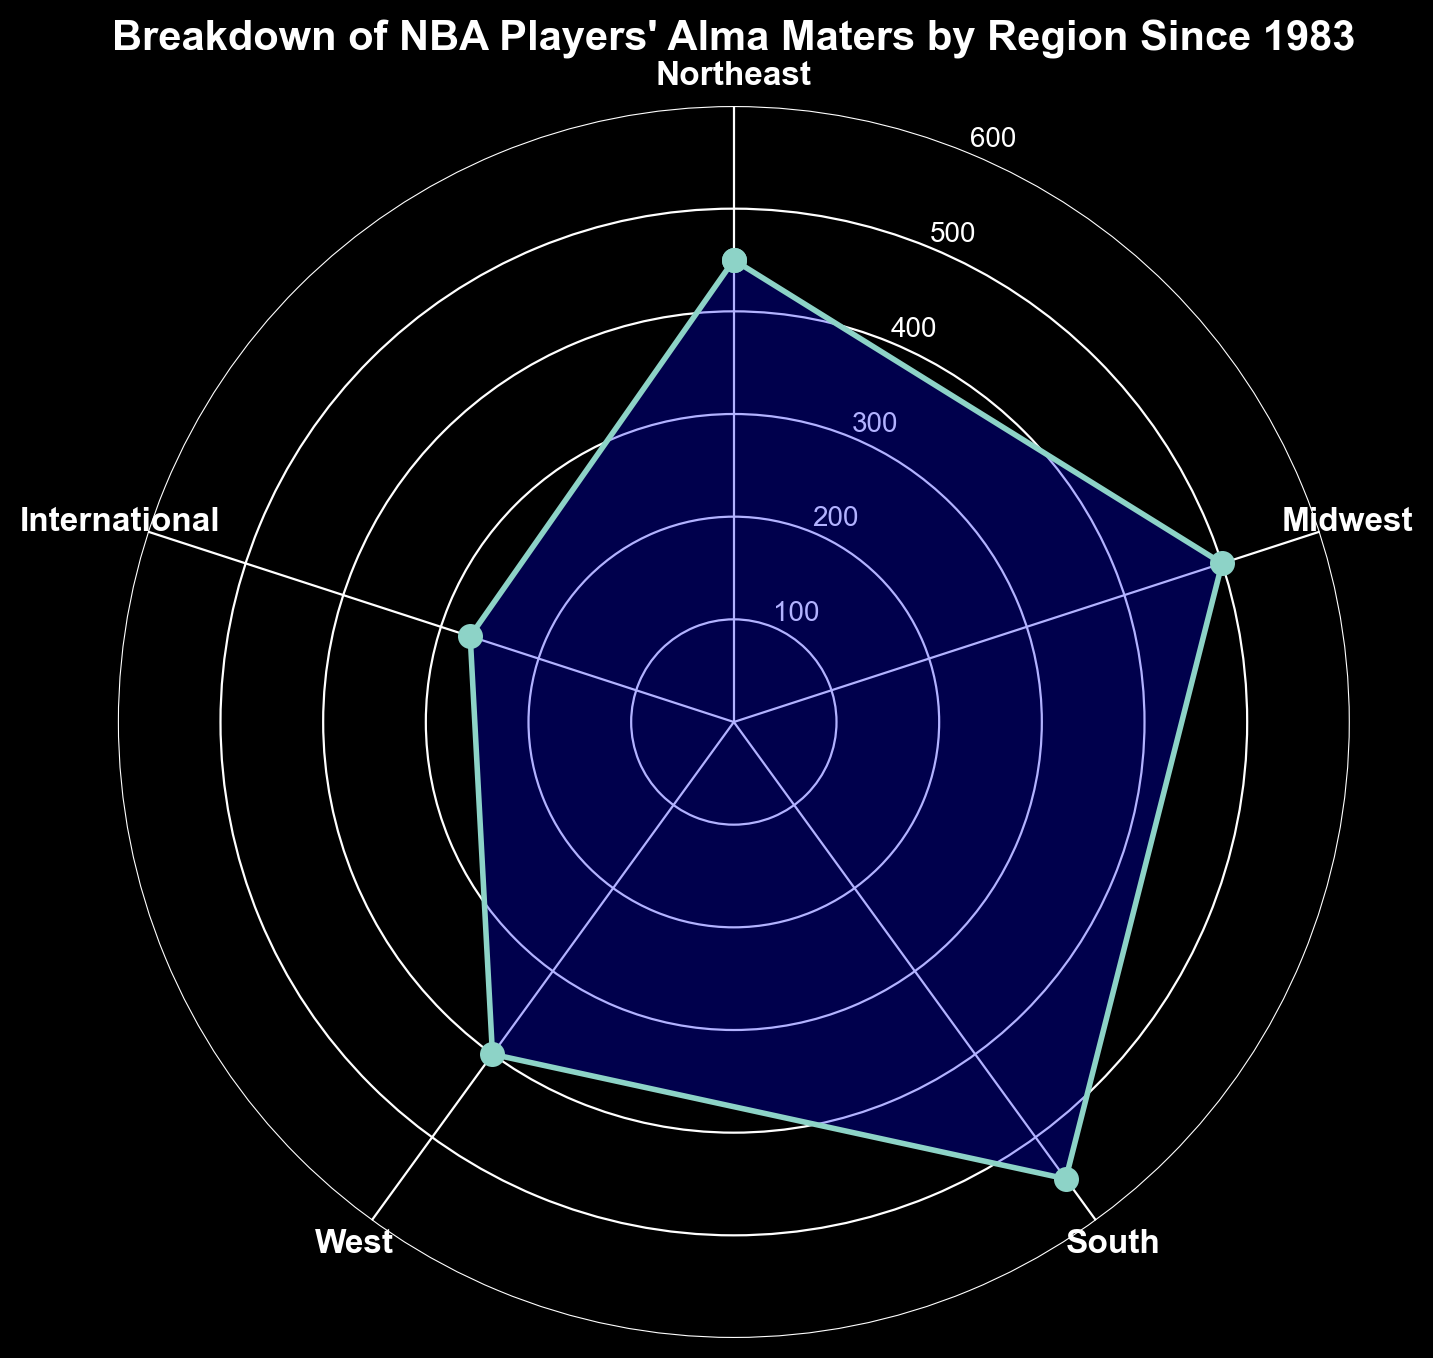Which region has produced the most NBA players since 1983? The plot shows "South" has the longest segment, indicating it has the highest number of players.
Answer: South How many more players are from the Midwest compared to the West? The plot shows the Midwest has 500 players and the West has 400. The difference is 500 - 400 = 100.
Answer: 100 What is the total number of NBA players from U.S. regions since 1983? The U.S. regions listed are Northeast (450), Midwest (500), South (550), and West (400). The total is 450 + 500 + 550 + 400 = 1900.
Answer: 1900 Which region has the fewest NBA players, and how many are there? The plot shows the "International" segment is the shortest with 270 players.
Answer: International, 270 What is the average number of players from the five regions shown? Summing the players from all regions: 450 (Northeast) + 500 (Midwest) + 550 (South) + 400 (West) + 270 (International) = 2170. Dividing by 5 regions, the average is 2170 / 5 = 434.
Answer: 434 How does the number of players from the Northeast compare to those from the International region? The plot shows the Northeast has 450 players and International has 270. 450 is greater than 270.
Answer: Northeast has more If the South and Midwest regions combined their players, how many would they have in total? The South has 550 players and the Midwest has 500. Combined, they would have 550 + 500 = 1050 players.
Answer: 1050 Which region is closest in player count to the average number of players across all regions? The average number of players is 434. Checking the numbers: Northeast (450), Midwest (500), South (550), West (400), International (270). The Northeast (450) is closest to 434.
Answer: Northeast What percentage of the total players does the South represent? Total players from all regions is 2170. The number from the South is 550. The percentage is (550 / 2170) * 100 = 25.35%.
Answer: 25.35% Which U.S. region has the lowest number of players and what is that number? The plot shows the West has the lowest U.S. region player count with 400 players.
Answer: West, 400 